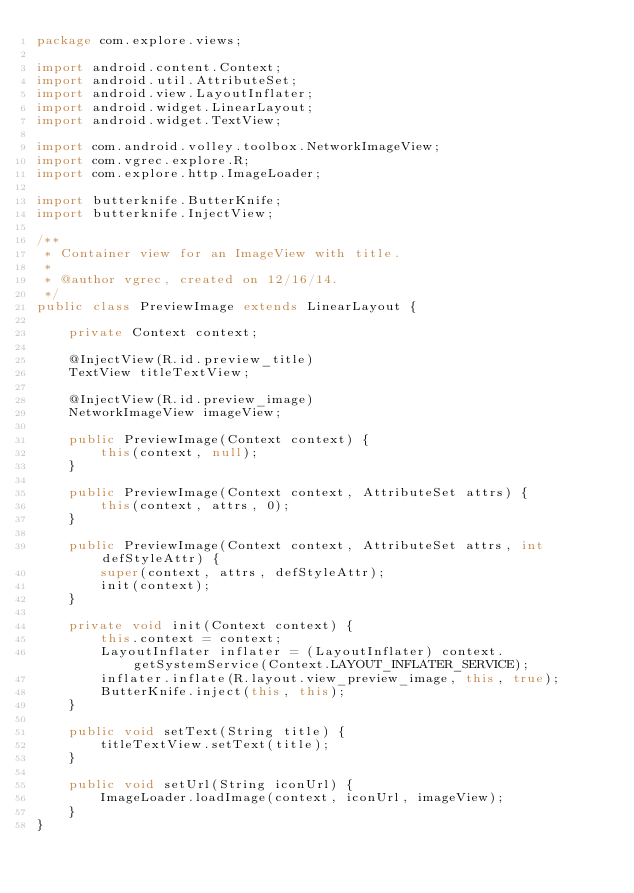<code> <loc_0><loc_0><loc_500><loc_500><_Java_>package com.explore.views;

import android.content.Context;
import android.util.AttributeSet;
import android.view.LayoutInflater;
import android.widget.LinearLayout;
import android.widget.TextView;

import com.android.volley.toolbox.NetworkImageView;
import com.vgrec.explore.R;
import com.explore.http.ImageLoader;

import butterknife.ButterKnife;
import butterknife.InjectView;

/**
 * Container view for an ImageView with title.
 *
 * @author vgrec, created on 12/16/14.
 */
public class PreviewImage extends LinearLayout {

    private Context context;

    @InjectView(R.id.preview_title)
    TextView titleTextView;

    @InjectView(R.id.preview_image)
    NetworkImageView imageView;

    public PreviewImage(Context context) {
        this(context, null);
    }

    public PreviewImage(Context context, AttributeSet attrs) {
        this(context, attrs, 0);
    }

    public PreviewImage(Context context, AttributeSet attrs, int defStyleAttr) {
        super(context, attrs, defStyleAttr);
        init(context);
    }

    private void init(Context context) {
        this.context = context;
        LayoutInflater inflater = (LayoutInflater) context.getSystemService(Context.LAYOUT_INFLATER_SERVICE);
        inflater.inflate(R.layout.view_preview_image, this, true);
        ButterKnife.inject(this, this);
    }

    public void setText(String title) {
        titleTextView.setText(title);
    }

    public void setUrl(String iconUrl) {
        ImageLoader.loadImage(context, iconUrl, imageView);
    }
}
</code> 